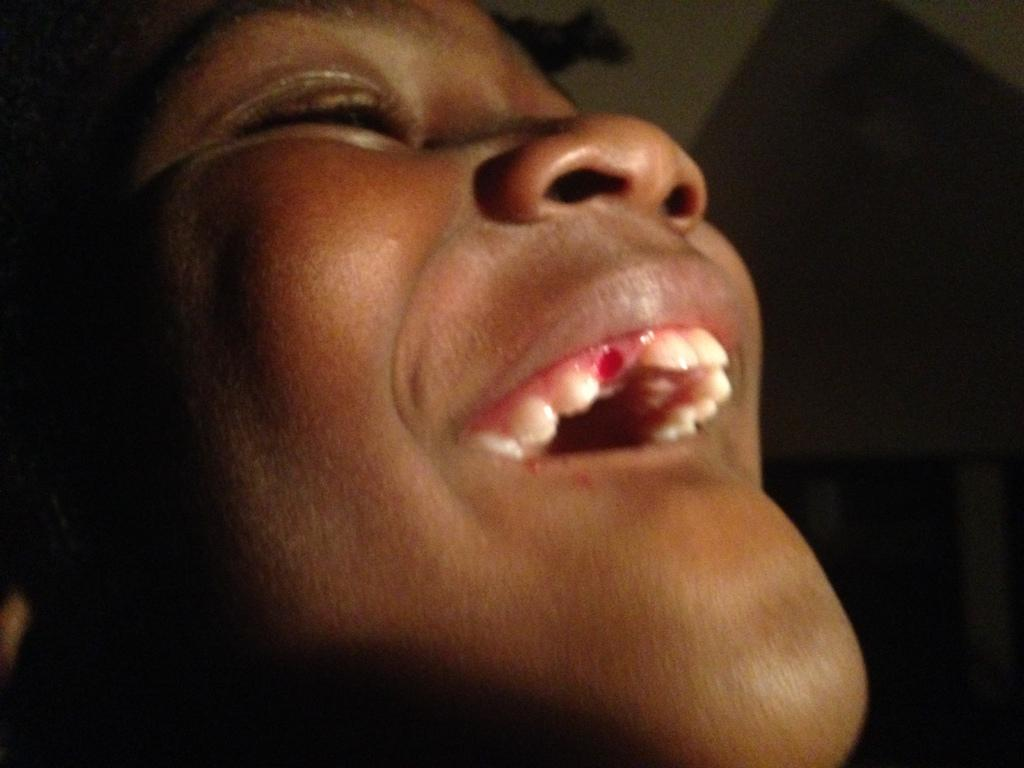What is the main subject of the image? There is a person in the center of the image. Can you describe the background of the image? There is a wall in the background of the image. How many feet are visible in the image? There is no mention of feet in the image, so it is not possible to determine how many are visible. 